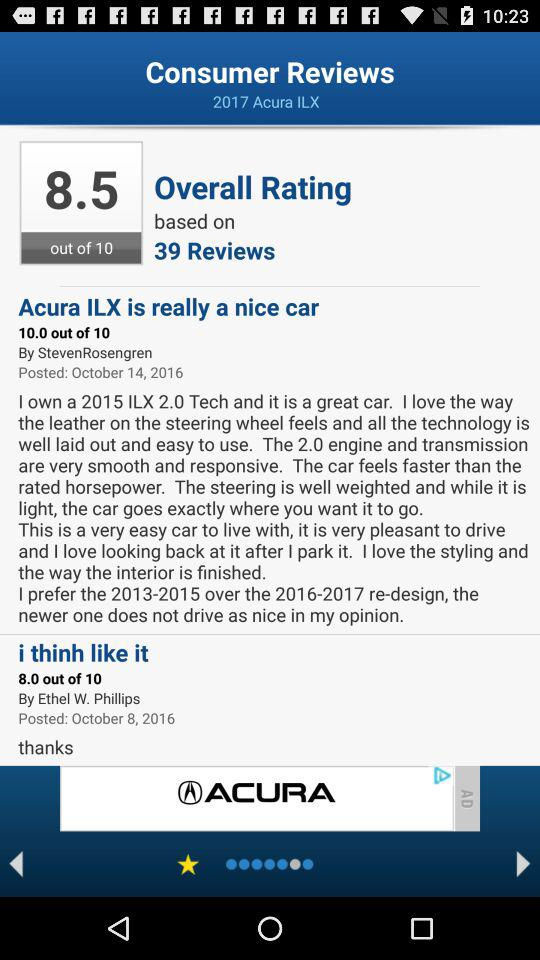By whom was the review "Acura ILX is really a nice car" shared? The review was shared by Steven Rosengren. 